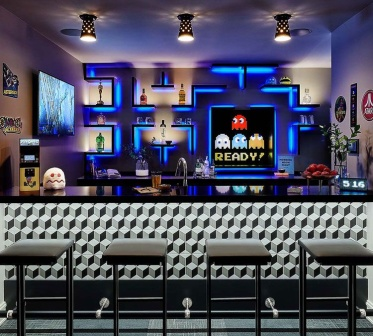What elements in this image highlight its retro gaming theme? The elements that highlight the retro gaming theme include the neon lights depicting Pac-Man and the ghosts, the small Pac-Man arcade cabinet on the left wall, and the prominent screen displaying 'PAC-MAN READY!'. Additionally, the black and white checkered pattern of the bar counter and floor adds a vintage vibe to the modern setup. 